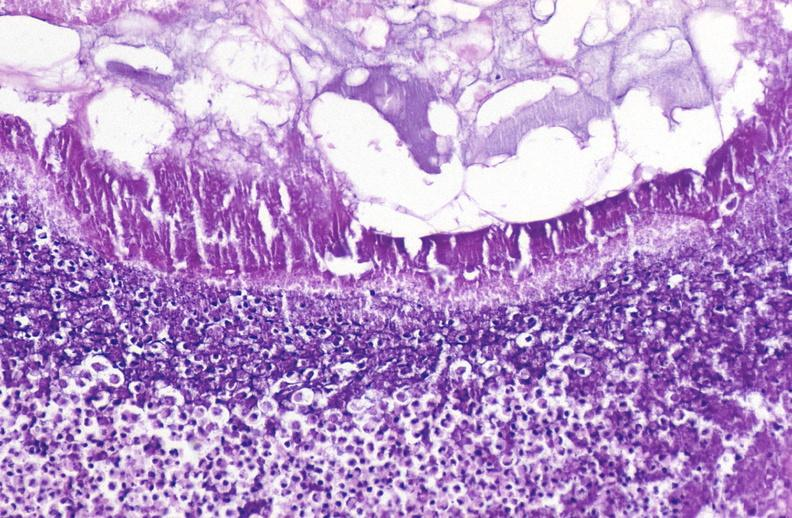does this image show pancreatic fat necrosis?
Answer the question using a single word or phrase. Yes 